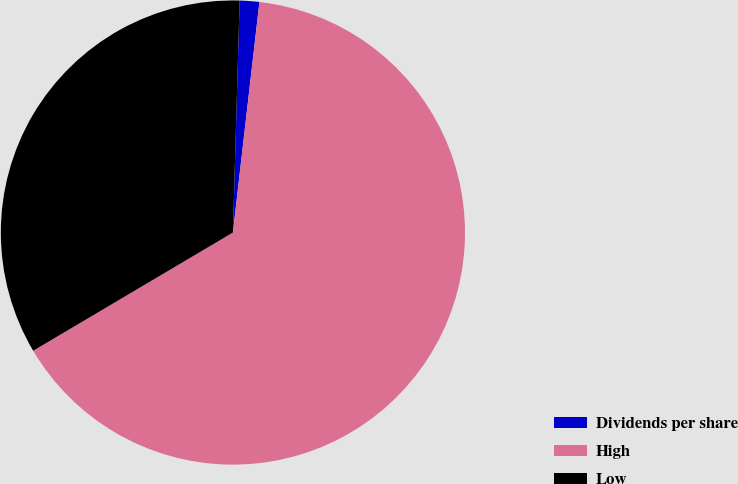<chart> <loc_0><loc_0><loc_500><loc_500><pie_chart><fcel>Dividends per share<fcel>High<fcel>Low<nl><fcel>1.36%<fcel>64.67%<fcel>33.97%<nl></chart> 